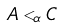<formula> <loc_0><loc_0><loc_500><loc_500>A < _ { \alpha } C</formula> 